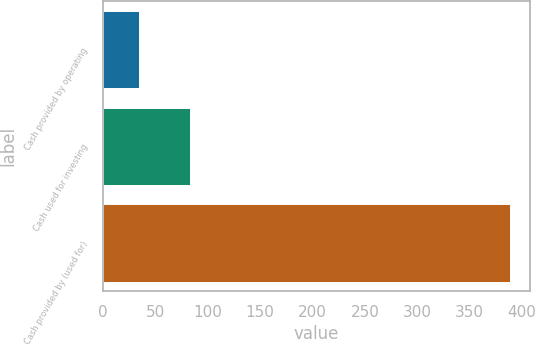Convert chart to OTSL. <chart><loc_0><loc_0><loc_500><loc_500><bar_chart><fcel>Cash provided by operating<fcel>Cash used for investing<fcel>Cash provided by (used for)<nl><fcel>34<fcel>83<fcel>388<nl></chart> 